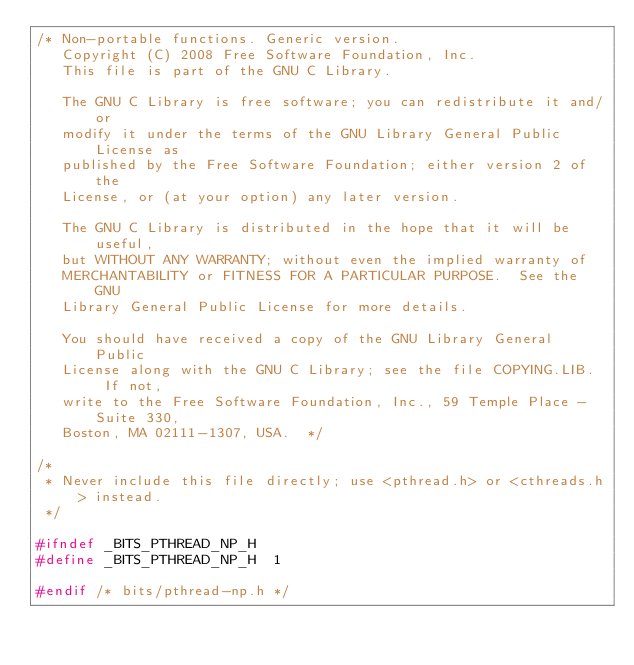<code> <loc_0><loc_0><loc_500><loc_500><_C_>/* Non-portable functions. Generic version.
   Copyright (C) 2008 Free Software Foundation, Inc.
   This file is part of the GNU C Library.

   The GNU C Library is free software; you can redistribute it and/or
   modify it under the terms of the GNU Library General Public License as
   published by the Free Software Foundation; either version 2 of the
   License, or (at your option) any later version.

   The GNU C Library is distributed in the hope that it will be useful,
   but WITHOUT ANY WARRANTY; without even the implied warranty of
   MERCHANTABILITY or FITNESS FOR A PARTICULAR PURPOSE.  See the GNU
   Library General Public License for more details.

   You should have received a copy of the GNU Library General Public
   License along with the GNU C Library; see the file COPYING.LIB.  If not,
   write to the Free Software Foundation, Inc., 59 Temple Place - Suite 330,
   Boston, MA 02111-1307, USA.  */

/*
 * Never include this file directly; use <pthread.h> or <cthreads.h> instead.
 */

#ifndef _BITS_PTHREAD_NP_H
#define _BITS_PTHREAD_NP_H	1

#endif /* bits/pthread-np.h */
</code> 